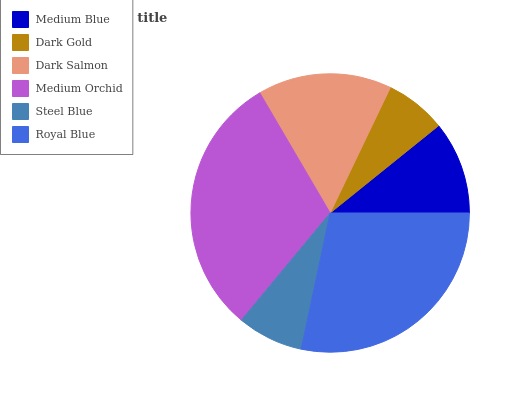Is Dark Gold the minimum?
Answer yes or no. Yes. Is Medium Orchid the maximum?
Answer yes or no. Yes. Is Dark Salmon the minimum?
Answer yes or no. No. Is Dark Salmon the maximum?
Answer yes or no. No. Is Dark Salmon greater than Dark Gold?
Answer yes or no. Yes. Is Dark Gold less than Dark Salmon?
Answer yes or no. Yes. Is Dark Gold greater than Dark Salmon?
Answer yes or no. No. Is Dark Salmon less than Dark Gold?
Answer yes or no. No. Is Dark Salmon the high median?
Answer yes or no. Yes. Is Medium Blue the low median?
Answer yes or no. Yes. Is Medium Blue the high median?
Answer yes or no. No. Is Dark Salmon the low median?
Answer yes or no. No. 